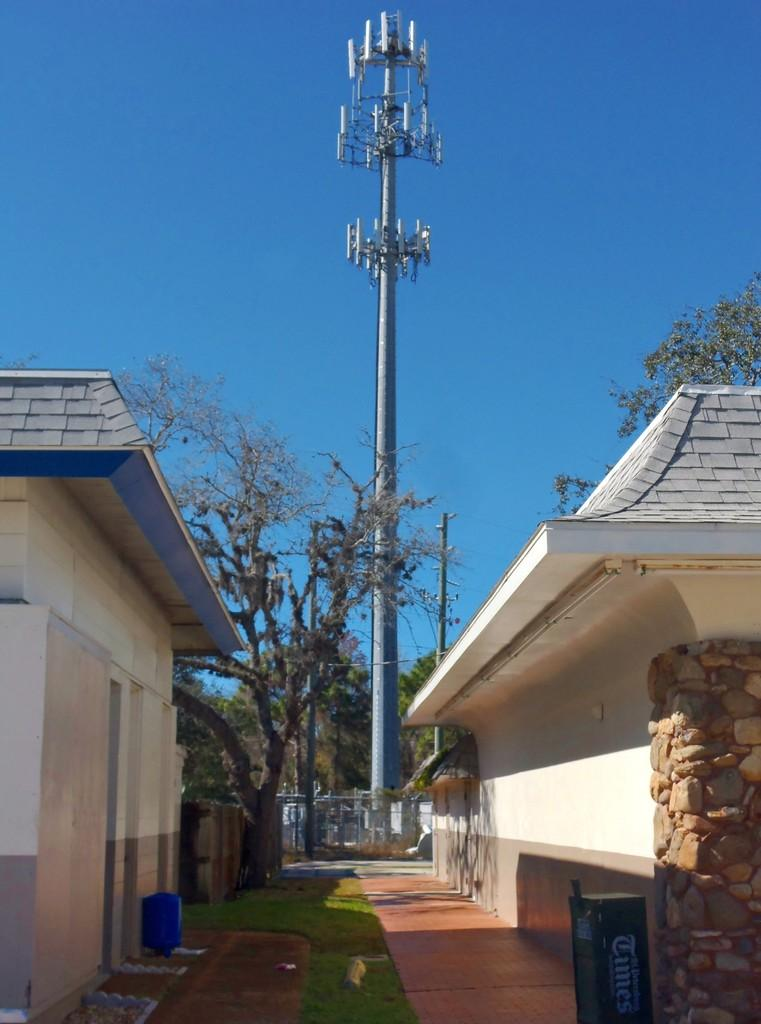What type of vegetation is present in the image? There is grass in the image. What can be seen in the image that might be used for walking? There is a path in the image. What type of structures are visible in the image? There are houses in the image. What other natural elements can be seen in the image? There are trees in the image. What are the poles used for in the image? The poles might be used for supporting wires or signs in the image. What is separating the grassy area from the houses? There is a fence in the image. What other objects can be seen in the image? There are some objects in the image, but their specific purpose is not clear. What is visible in the background of the image? The sky is visible in the background of the image. What type of pencil is being used to draw the arch in the image? There is no pencil or arch present in the image; it features a more natural scene with grass, path, houses, trees, poles, fence, and objects. Can you tell me how many grandfathers are sitting on the fence in the image? There are no people, including grandfathers, present in the image; it only features natural elements and objects. 